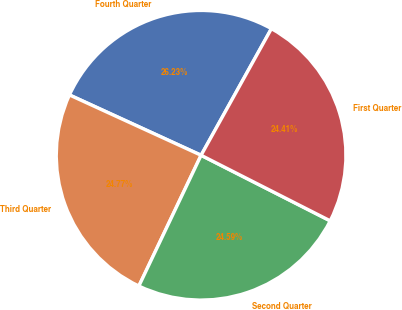<chart> <loc_0><loc_0><loc_500><loc_500><pie_chart><fcel>Fourth Quarter<fcel>Third Quarter<fcel>Second Quarter<fcel>First Quarter<nl><fcel>26.23%<fcel>24.77%<fcel>24.59%<fcel>24.41%<nl></chart> 